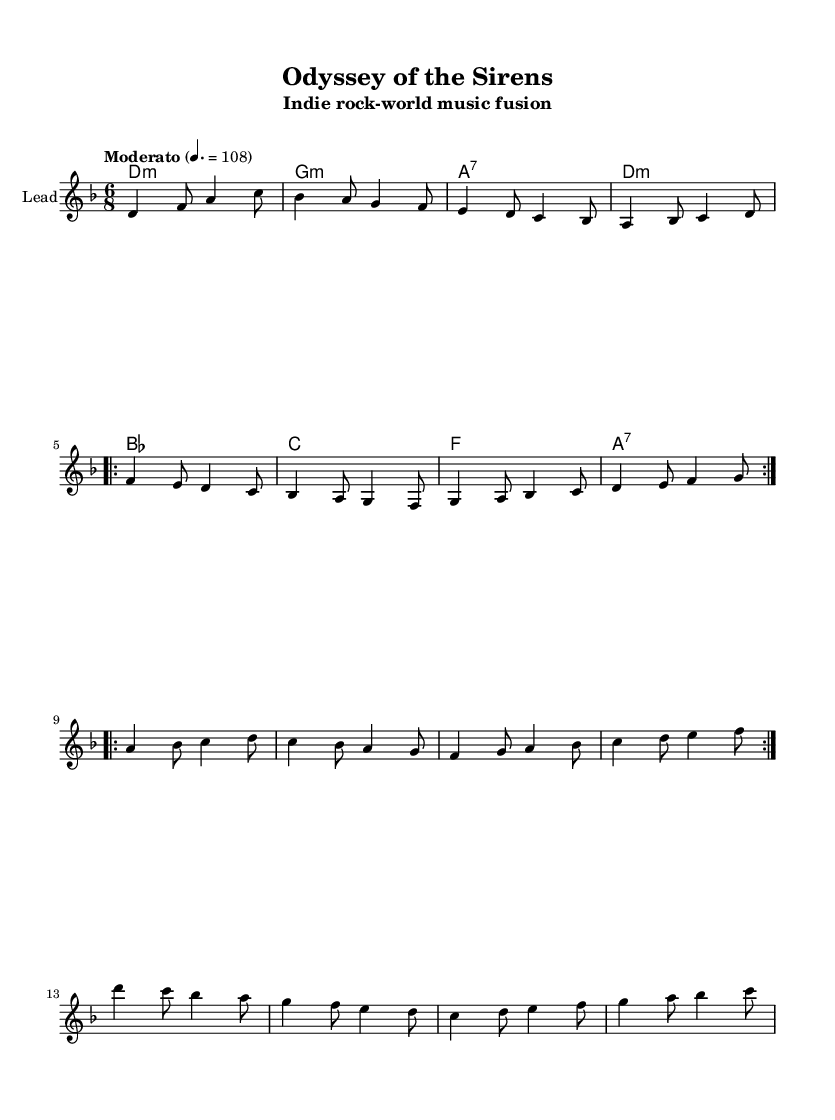What is the key signature of this music? The key signature is two flats, which indicates the key of D minor. In the key signature section, we see that there are two flat symbols placed on the F and B lines.
Answer: D minor What is the time signature of this music? The time signature is 6/8, which means there are six eighth notes per measure. This is indicated at the beginning of the score.
Answer: 6/8 What is the tempo marking for this piece? The tempo marking indicates "Moderato," which suggests a moderate speed for the performance of the piece. This marking appears at the start of the score, alongside the metronome mark of 108.
Answer: Moderato How many times is the verse repeated? The verse section is repeated two times, as indicated by the notation "repeat volta 2" placed before the verse measures. This indicates that the performer should play the verse section twice consecutively.
Answer: 2 What type of chord is used in measure 4? In measure 4, the chord is an A7 chord. Chords in the harmonies section can be identified by their notation, and here it is indicated as "a2.:7."
Answer: A7 What is the predominant music fusion style of this piece? The piece primarily fuses indie rock with world music elements, which is indicated by the title "Odyssey of the Sirens" and the unique rhythmic and melodic patterns that suggest influences from folklore and mythology.
Answer: Indie rock-world music fusion What is the last note of the bridge section? The last note of the bridge section is C, found on the last measure of the bridge. This can be identified by the notation in the melody and is consistent with the measure's count.
Answer: C 